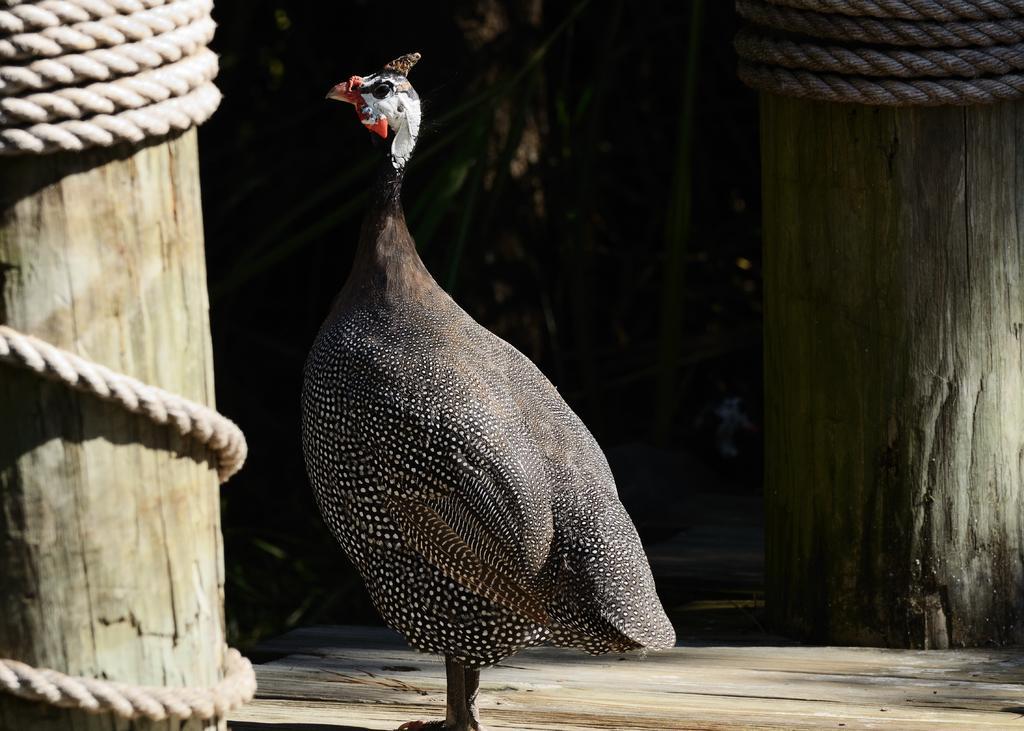In one or two sentences, can you explain what this image depicts? In the center of the image we can see a bird on the ground. Image also consists of two wooden pillars with ropes. 